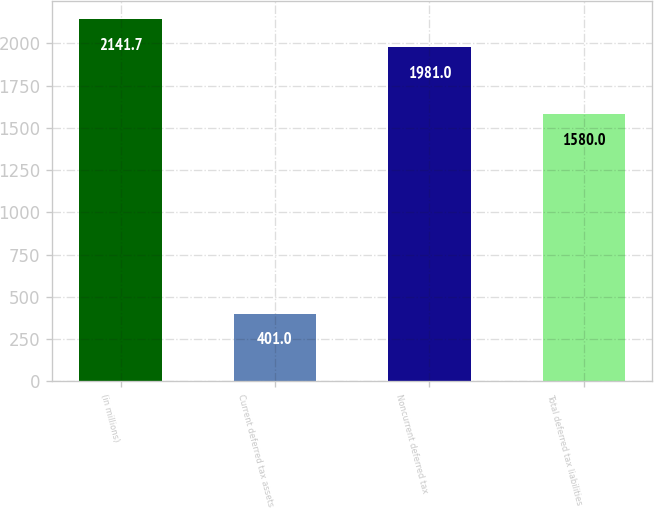Convert chart. <chart><loc_0><loc_0><loc_500><loc_500><bar_chart><fcel>(in millions)<fcel>Current deferred tax assets<fcel>Noncurrent deferred tax<fcel>Total deferred tax liabilities<nl><fcel>2141.7<fcel>401<fcel>1981<fcel>1580<nl></chart> 